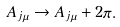<formula> <loc_0><loc_0><loc_500><loc_500>A _ { j \mu } \rightarrow A _ { j \mu } + 2 \pi .</formula> 